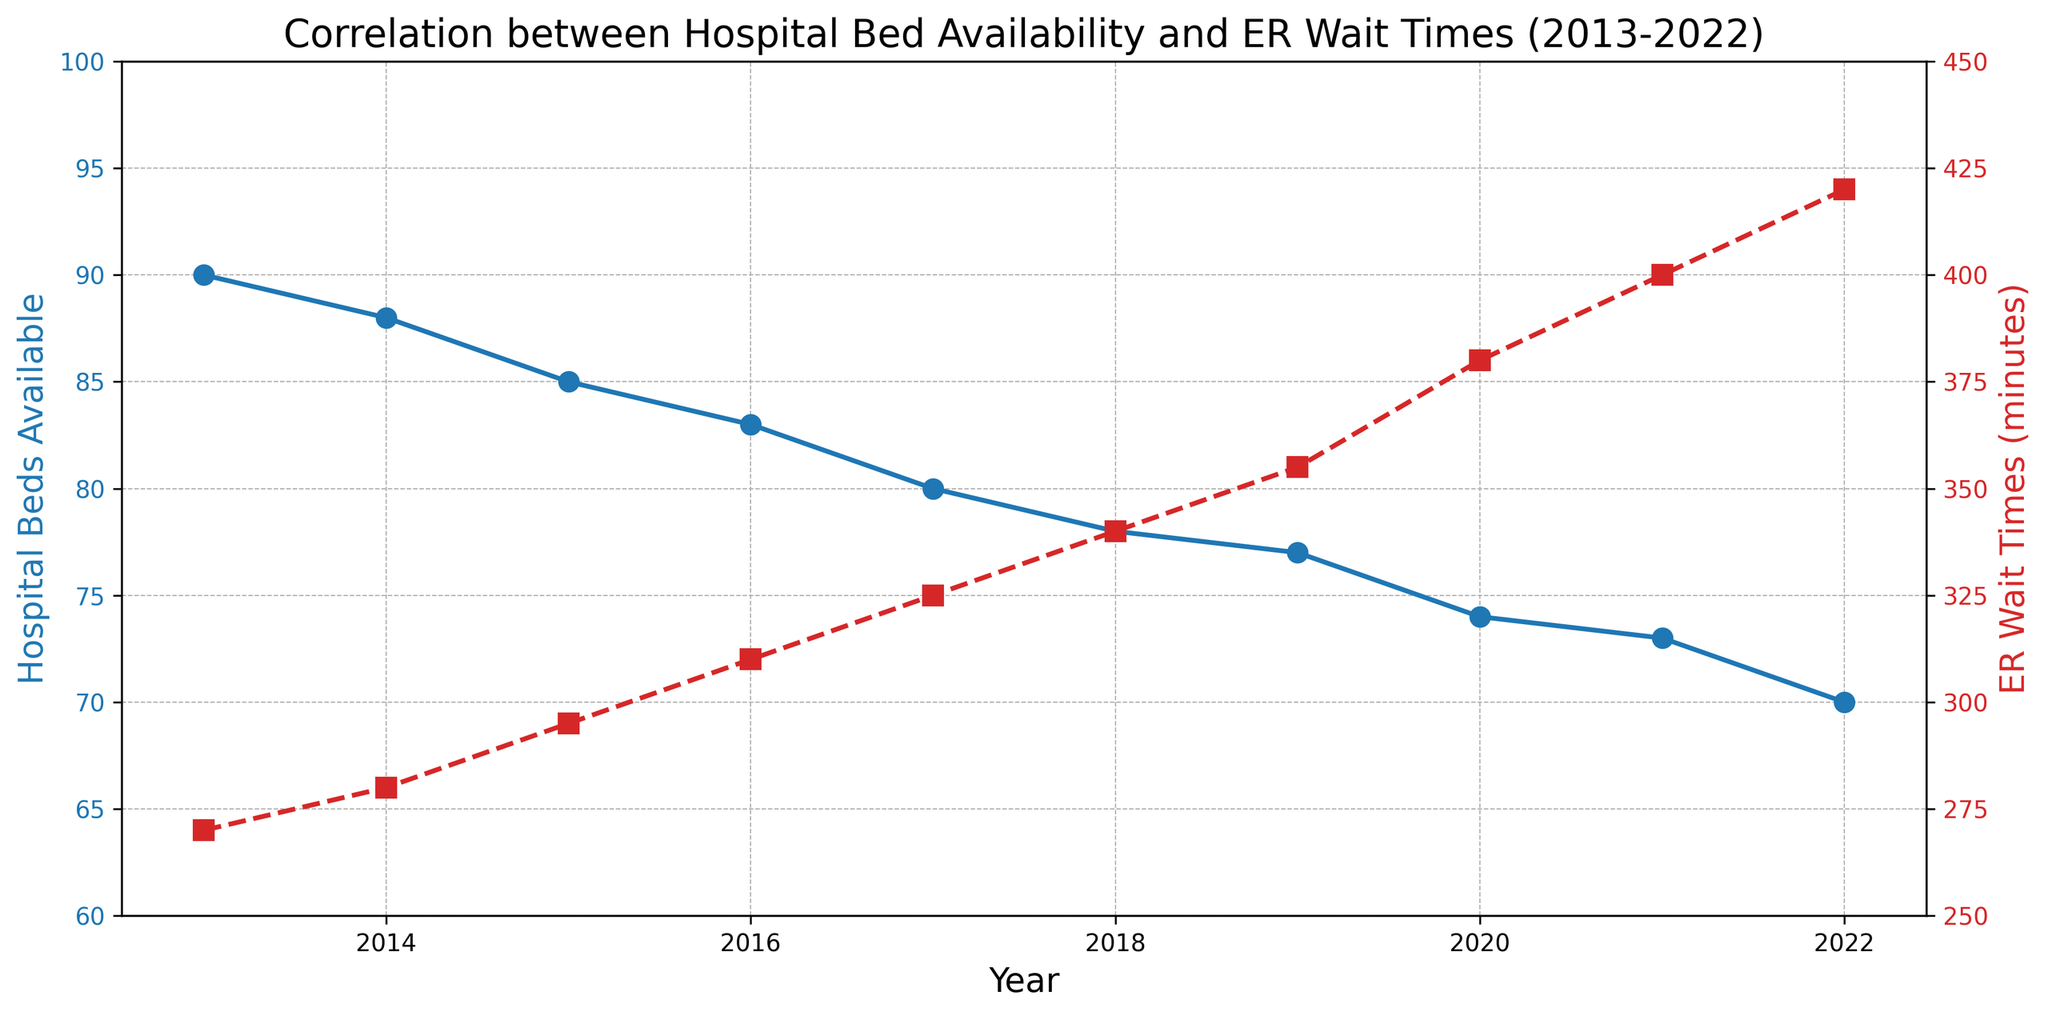What trends can you observe between hospital bed availability and ER wait times from 2013 to 2022? The figure shows a decreasing trend in hospital bed availability from 90 beds in 2013 to 70 beds in 2022, while ER wait times increase from 270 minutes in 2013 to 420 minutes in 2022.
Answer: Hospital bed availability decreases; ER wait times increase In which year were ER wait times the highest? By examining the red dashed line representing ER wait times, it peaks at 420 minutes in the year 2022.
Answer: 2022 How does the number of hospital beds in 2022 compare to the number of beds available in 2013? The initial value in 2013 is 90 beds and the final value in 2022 is 70 beds. Therefore, 2022 had 20 fewer hospital beds compared to 2013.
Answer: 20 fewer beds What is the correlation between hospital bed availability and ER wait times over this period? As hospital bed availability decreases (blue line trend), ER wait times increase (red dashed line trend), indicating an inverse correlation.
Answer: Inverse correlation Which year experienced the sharpest increase in ER wait times compared to the previous year? The most significant annual increase in ER wait times occurs between 2019 and 2020, rising from 355 to 380 minutes, an increase of 25 minutes.
Answer: 2020 How much did hospital bed availability decrease on average per year? Starting from 90 beds in 2013 and dropping to 70 beds in 2022 over 9 years, the total decrease is 20 beds. Therefore, 20 beds / 9 years ≈ 2.22 beds per year.
Answer: Approximately 2.22 beds per year Identify the year with the sharpest decline in hospital bed availability compared to the previous year. The most considerable annual decline in hospital bed availability is between 2016 and 2017, where it decreases from 83 to 80 beds, a drop of 3 beds.
Answer: 2017 In what year did hospital bed availability drop below 80 beds? The blue line representing hospital bed availability drops below 80 in 2017 and stays below this number thereafter.
Answer: 2017 What was the ER wait time in 2016, and how does it differ from the wait time in 2020? The ER wait time in 2016 was 310 minutes, while in 2020 it was 380 minutes. The difference is 380 - 310 = 70 minutes.
Answer: 70 minutes Comparatively, how much did ER wait times increase between 2013 and 2017? ER wait times increased from 270 minutes in 2013 to 325 minutes in 2017. The difference is 325 - 270 = 55 minutes.
Answer: 55 minutes 